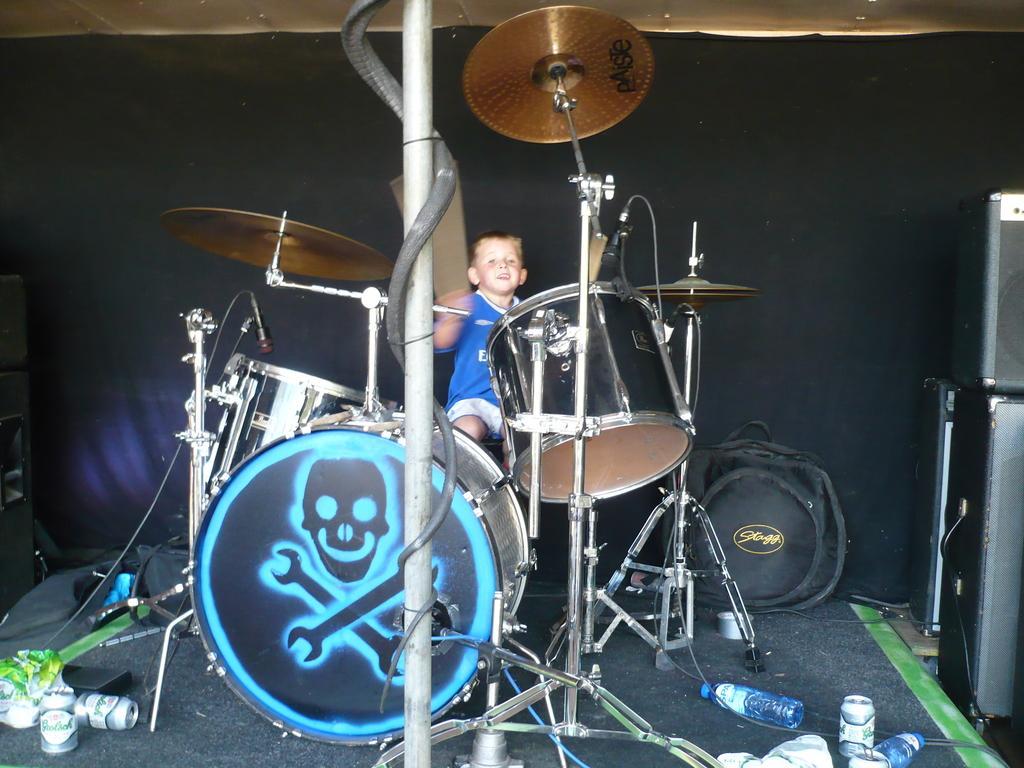How would you summarize this image in a sentence or two? In this picture we can see a boy sitting and in front of him we can see drums, mics, bottles, tins, bag, speakers and in the background we can see a cloth. 